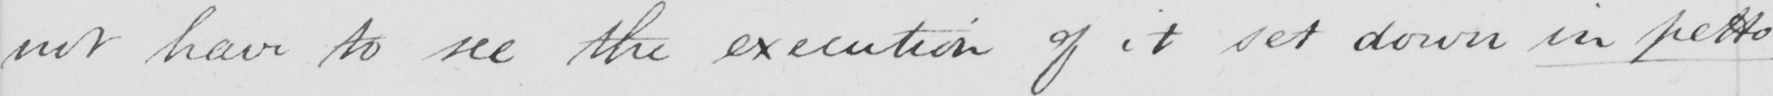Transcribe the text shown in this historical manuscript line. not have to see the execution of it set down in petto 